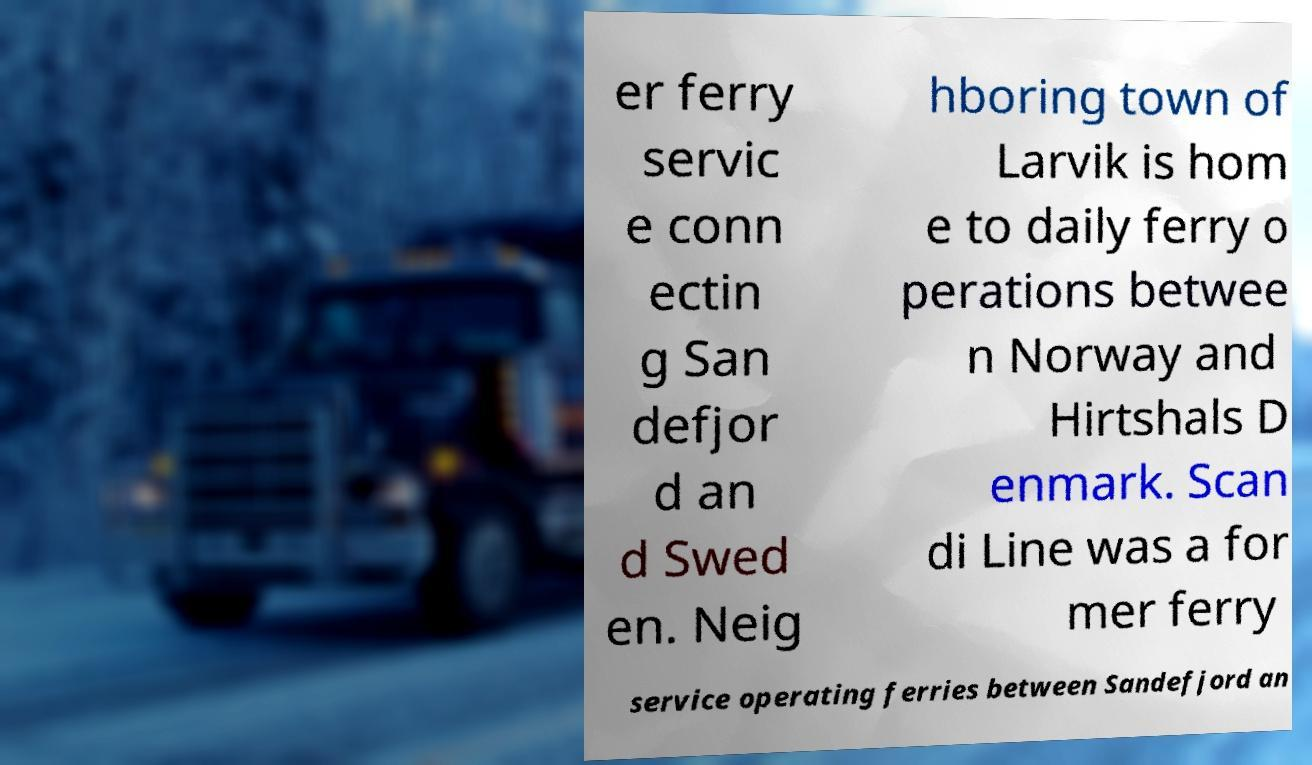There's text embedded in this image that I need extracted. Can you transcribe it verbatim? er ferry servic e conn ectin g San defjor d an d Swed en. Neig hboring town of Larvik is hom e to daily ferry o perations betwee n Norway and Hirtshals D enmark. Scan di Line was a for mer ferry service operating ferries between Sandefjord an 